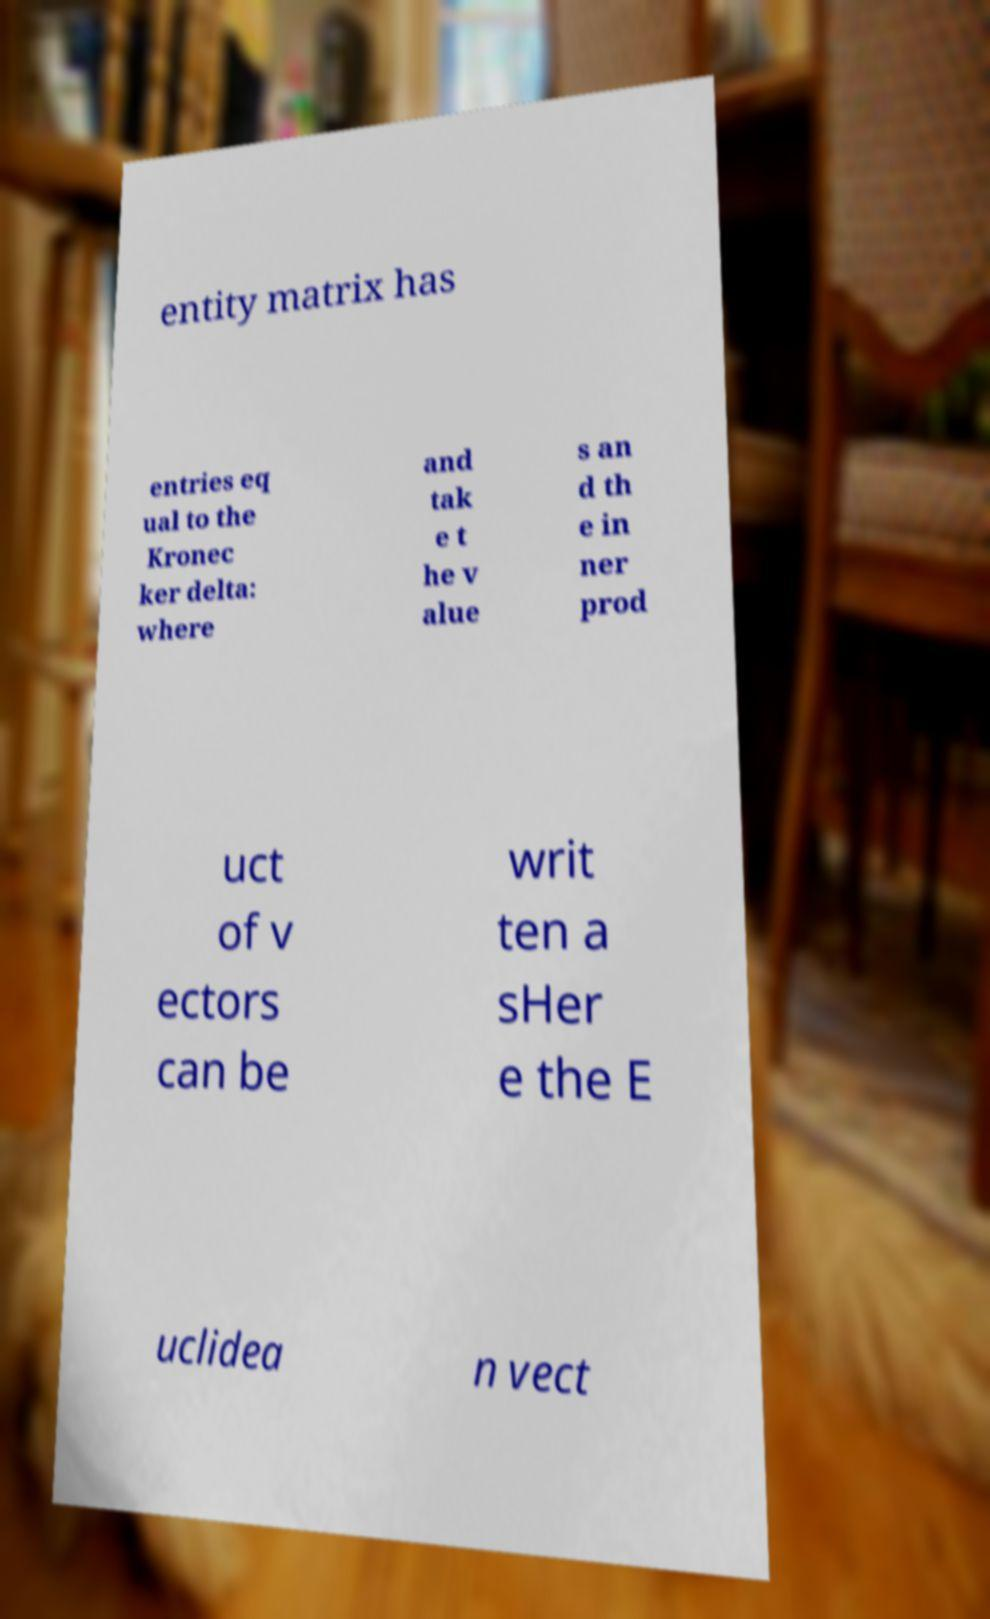For documentation purposes, I need the text within this image transcribed. Could you provide that? entity matrix has entries eq ual to the Kronec ker delta: where and tak e t he v alue s an d th e in ner prod uct of v ectors can be writ ten a sHer e the E uclidea n vect 